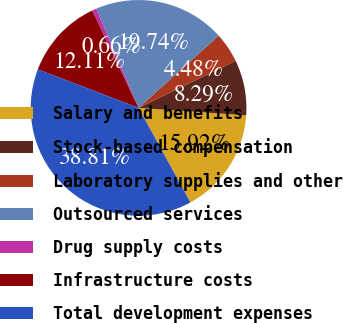Convert chart to OTSL. <chart><loc_0><loc_0><loc_500><loc_500><pie_chart><fcel>Salary and benefits<fcel>Stock-based compensation<fcel>Laboratory supplies and other<fcel>Outsourced services<fcel>Drug supply costs<fcel>Infrastructure costs<fcel>Total development expenses<nl><fcel>15.92%<fcel>8.29%<fcel>4.48%<fcel>19.74%<fcel>0.66%<fcel>12.11%<fcel>38.81%<nl></chart> 